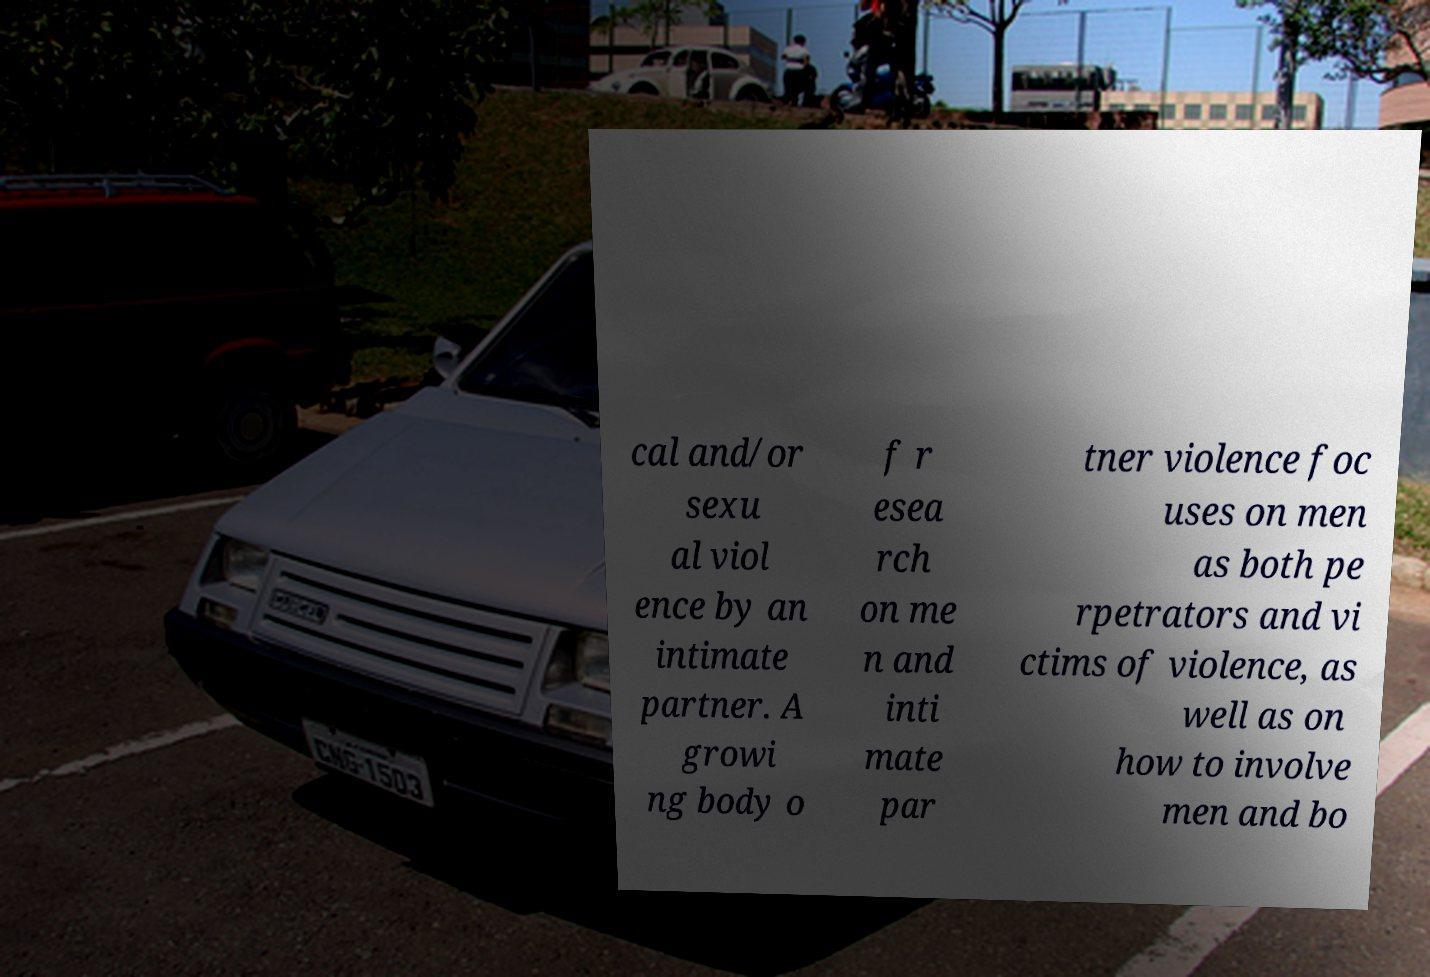There's text embedded in this image that I need extracted. Can you transcribe it verbatim? cal and/or sexu al viol ence by an intimate partner. A growi ng body o f r esea rch on me n and inti mate par tner violence foc uses on men as both pe rpetrators and vi ctims of violence, as well as on how to involve men and bo 